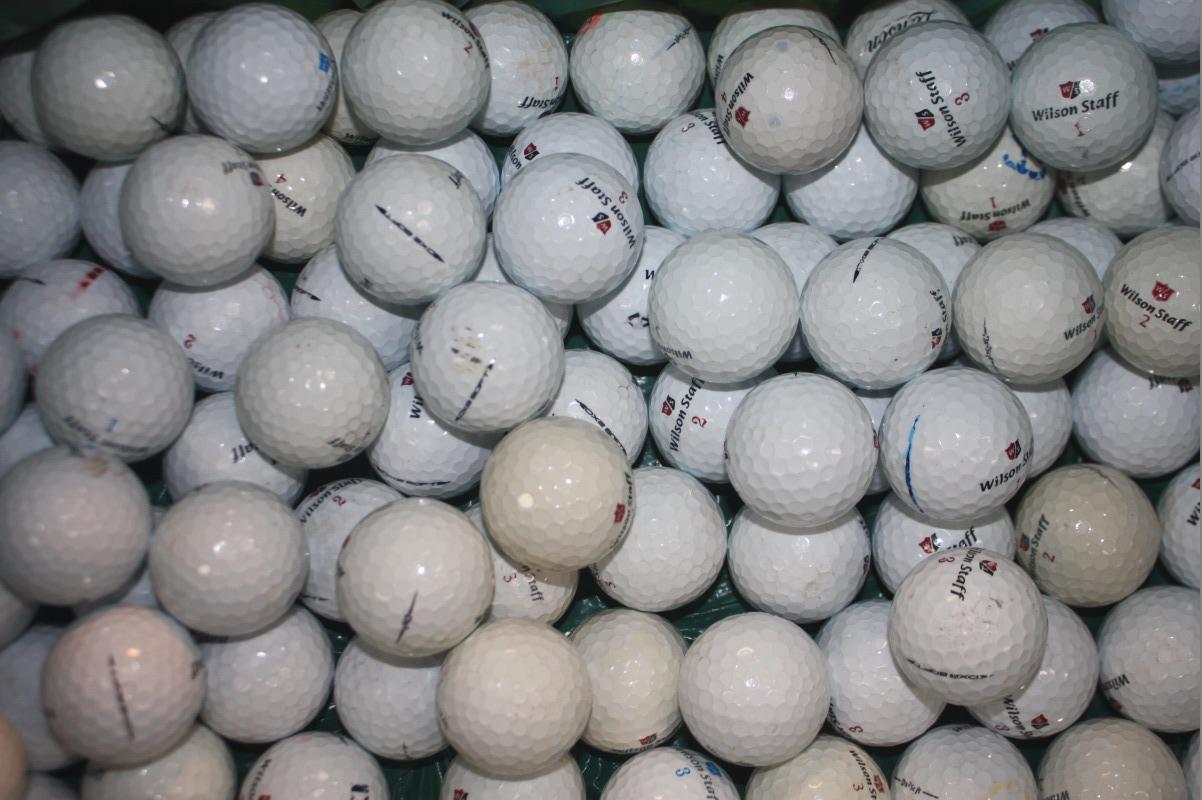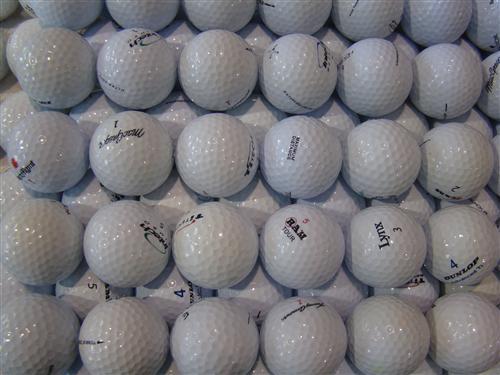The first image is the image on the left, the second image is the image on the right. Examine the images to the left and right. Is the description "Some of the balls are colorful." accurate? Answer yes or no. No. 